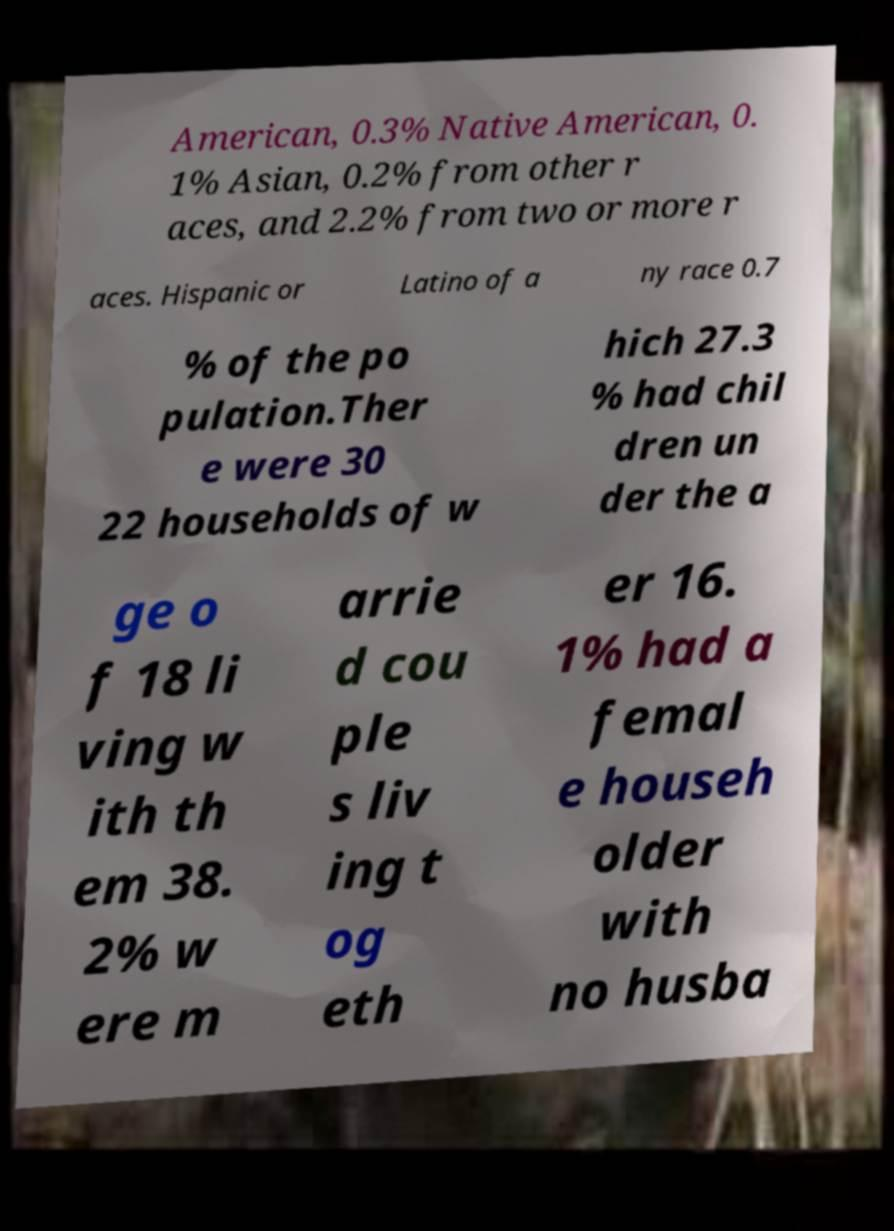Could you assist in decoding the text presented in this image and type it out clearly? American, 0.3% Native American, 0. 1% Asian, 0.2% from other r aces, and 2.2% from two or more r aces. Hispanic or Latino of a ny race 0.7 % of the po pulation.Ther e were 30 22 households of w hich 27.3 % had chil dren un der the a ge o f 18 li ving w ith th em 38. 2% w ere m arrie d cou ple s liv ing t og eth er 16. 1% had a femal e househ older with no husba 